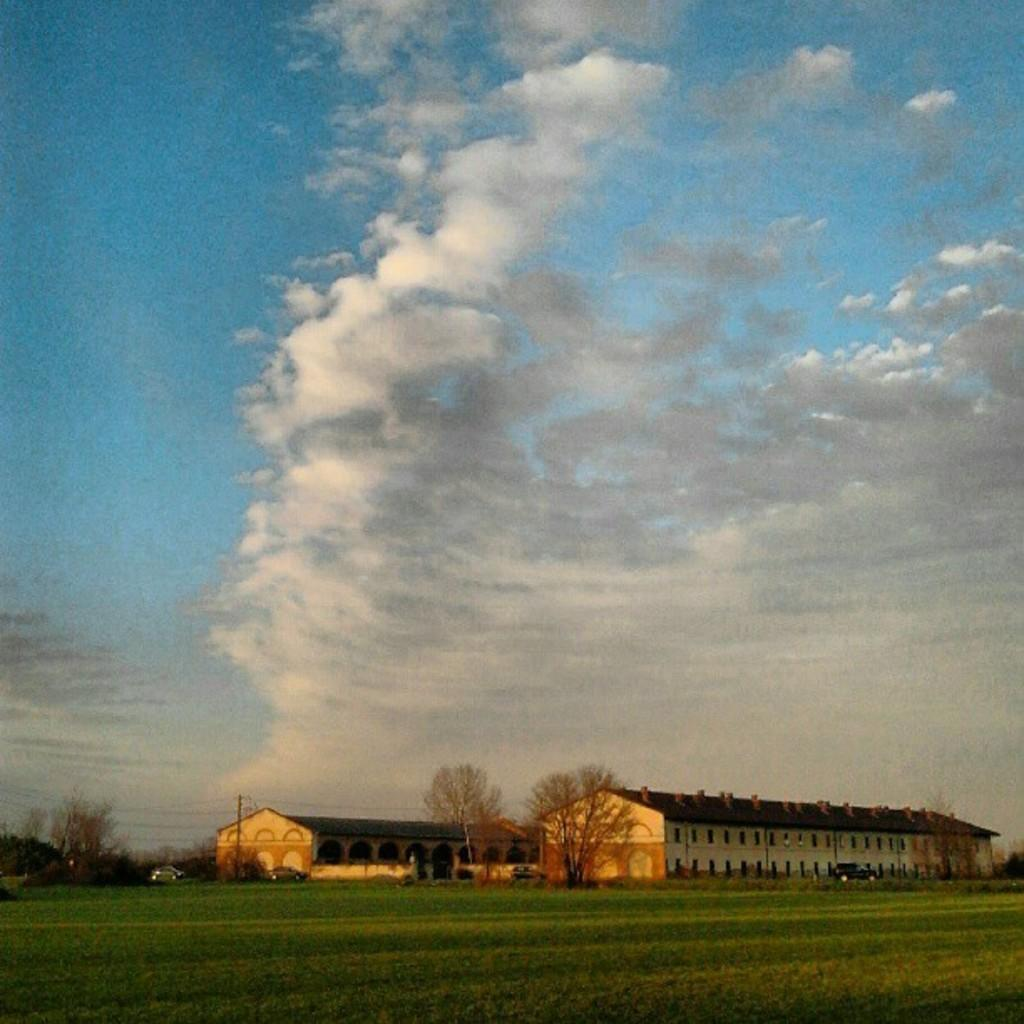What type of structures can be seen in the image? There are buildings in the image. What feature is visible on the buildings? There are windows visible in the image. What type of natural elements are present in the image? There are trees in the image. What type of transportation is visible in the image? Vehicles are present in the image. What type of infrastructure is visible in the image? Current poles are visible in the image. What type of utility is present in the image? Wires are present in the image. What is the color of the sky in the image? The sky is a combination of white and blue colors. How many feet are visible on the cub in the image? There is no cub present in the image, and therefore no feet to count. What type of toys can be seen in the image? There are no toys present in the image. 